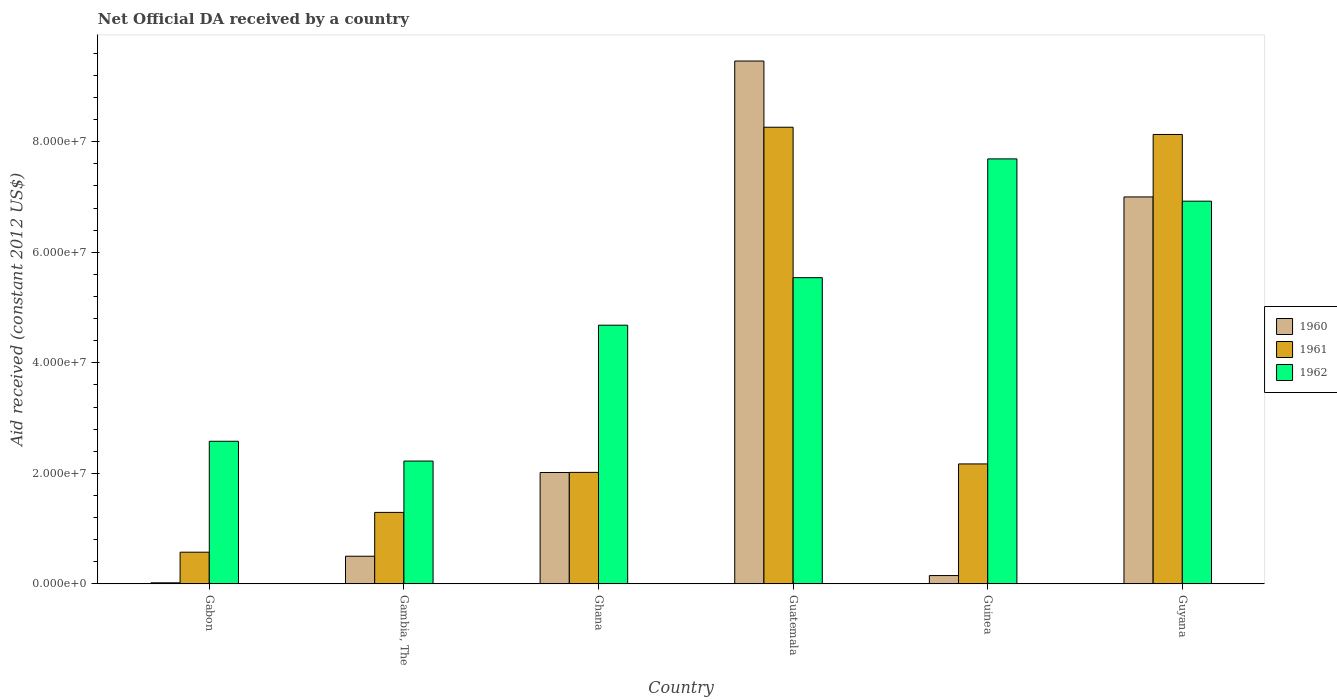How many different coloured bars are there?
Provide a short and direct response. 3. How many groups of bars are there?
Your answer should be very brief. 6. Are the number of bars on each tick of the X-axis equal?
Your answer should be compact. Yes. How many bars are there on the 2nd tick from the left?
Make the answer very short. 3. What is the label of the 6th group of bars from the left?
Keep it short and to the point. Guyana. What is the net official development assistance aid received in 1960 in Guatemala?
Provide a succinct answer. 9.46e+07. Across all countries, what is the maximum net official development assistance aid received in 1960?
Your response must be concise. 9.46e+07. Across all countries, what is the minimum net official development assistance aid received in 1962?
Give a very brief answer. 2.22e+07. In which country was the net official development assistance aid received in 1960 maximum?
Give a very brief answer. Guatemala. In which country was the net official development assistance aid received in 1962 minimum?
Your response must be concise. Gambia, The. What is the total net official development assistance aid received in 1961 in the graph?
Your answer should be compact. 2.24e+08. What is the difference between the net official development assistance aid received in 1962 in Guatemala and that in Guinea?
Ensure brevity in your answer.  -2.15e+07. What is the difference between the net official development assistance aid received in 1962 in Guatemala and the net official development assistance aid received in 1961 in Guyana?
Your answer should be compact. -2.59e+07. What is the average net official development assistance aid received in 1960 per country?
Provide a succinct answer. 3.19e+07. What is the difference between the net official development assistance aid received of/in 1961 and net official development assistance aid received of/in 1962 in Guyana?
Provide a short and direct response. 1.21e+07. What is the ratio of the net official development assistance aid received in 1960 in Gabon to that in Guyana?
Give a very brief answer. 0. Is the difference between the net official development assistance aid received in 1961 in Gabon and Gambia, The greater than the difference between the net official development assistance aid received in 1962 in Gabon and Gambia, The?
Your answer should be very brief. No. What is the difference between the highest and the second highest net official development assistance aid received in 1961?
Ensure brevity in your answer.  1.31e+06. What is the difference between the highest and the lowest net official development assistance aid received in 1962?
Ensure brevity in your answer.  5.47e+07. What does the 1st bar from the left in Guatemala represents?
Keep it short and to the point. 1960. Is it the case that in every country, the sum of the net official development assistance aid received in 1961 and net official development assistance aid received in 1960 is greater than the net official development assistance aid received in 1962?
Offer a terse response. No. How many bars are there?
Make the answer very short. 18. Are all the bars in the graph horizontal?
Give a very brief answer. No. What is the difference between two consecutive major ticks on the Y-axis?
Give a very brief answer. 2.00e+07. Are the values on the major ticks of Y-axis written in scientific E-notation?
Make the answer very short. Yes. Does the graph contain grids?
Ensure brevity in your answer.  No. Where does the legend appear in the graph?
Ensure brevity in your answer.  Center right. How are the legend labels stacked?
Make the answer very short. Vertical. What is the title of the graph?
Keep it short and to the point. Net Official DA received by a country. What is the label or title of the Y-axis?
Your response must be concise. Aid received (constant 2012 US$). What is the Aid received (constant 2012 US$) of 1960 in Gabon?
Offer a very short reply. 1.90e+05. What is the Aid received (constant 2012 US$) in 1961 in Gabon?
Your response must be concise. 5.73e+06. What is the Aid received (constant 2012 US$) of 1962 in Gabon?
Keep it short and to the point. 2.58e+07. What is the Aid received (constant 2012 US$) in 1961 in Gambia, The?
Ensure brevity in your answer.  1.29e+07. What is the Aid received (constant 2012 US$) in 1962 in Gambia, The?
Your answer should be very brief. 2.22e+07. What is the Aid received (constant 2012 US$) of 1960 in Ghana?
Your answer should be compact. 2.02e+07. What is the Aid received (constant 2012 US$) in 1961 in Ghana?
Give a very brief answer. 2.02e+07. What is the Aid received (constant 2012 US$) of 1962 in Ghana?
Your response must be concise. 4.68e+07. What is the Aid received (constant 2012 US$) of 1960 in Guatemala?
Your answer should be compact. 9.46e+07. What is the Aid received (constant 2012 US$) of 1961 in Guatemala?
Keep it short and to the point. 8.26e+07. What is the Aid received (constant 2012 US$) in 1962 in Guatemala?
Your answer should be compact. 5.54e+07. What is the Aid received (constant 2012 US$) in 1960 in Guinea?
Give a very brief answer. 1.50e+06. What is the Aid received (constant 2012 US$) in 1961 in Guinea?
Make the answer very short. 2.17e+07. What is the Aid received (constant 2012 US$) in 1962 in Guinea?
Make the answer very short. 7.69e+07. What is the Aid received (constant 2012 US$) of 1960 in Guyana?
Ensure brevity in your answer.  7.00e+07. What is the Aid received (constant 2012 US$) of 1961 in Guyana?
Make the answer very short. 8.13e+07. What is the Aid received (constant 2012 US$) of 1962 in Guyana?
Offer a very short reply. 6.92e+07. Across all countries, what is the maximum Aid received (constant 2012 US$) in 1960?
Keep it short and to the point. 9.46e+07. Across all countries, what is the maximum Aid received (constant 2012 US$) of 1961?
Your answer should be very brief. 8.26e+07. Across all countries, what is the maximum Aid received (constant 2012 US$) in 1962?
Make the answer very short. 7.69e+07. Across all countries, what is the minimum Aid received (constant 2012 US$) in 1961?
Provide a short and direct response. 5.73e+06. Across all countries, what is the minimum Aid received (constant 2012 US$) in 1962?
Ensure brevity in your answer.  2.22e+07. What is the total Aid received (constant 2012 US$) of 1960 in the graph?
Your answer should be very brief. 1.91e+08. What is the total Aid received (constant 2012 US$) of 1961 in the graph?
Provide a short and direct response. 2.24e+08. What is the total Aid received (constant 2012 US$) of 1962 in the graph?
Provide a short and direct response. 2.96e+08. What is the difference between the Aid received (constant 2012 US$) in 1960 in Gabon and that in Gambia, The?
Give a very brief answer. -4.81e+06. What is the difference between the Aid received (constant 2012 US$) of 1961 in Gabon and that in Gambia, The?
Give a very brief answer. -7.20e+06. What is the difference between the Aid received (constant 2012 US$) in 1962 in Gabon and that in Gambia, The?
Offer a terse response. 3.58e+06. What is the difference between the Aid received (constant 2012 US$) in 1960 in Gabon and that in Ghana?
Your response must be concise. -2.00e+07. What is the difference between the Aid received (constant 2012 US$) in 1961 in Gabon and that in Ghana?
Ensure brevity in your answer.  -1.44e+07. What is the difference between the Aid received (constant 2012 US$) of 1962 in Gabon and that in Ghana?
Make the answer very short. -2.10e+07. What is the difference between the Aid received (constant 2012 US$) of 1960 in Gabon and that in Guatemala?
Provide a succinct answer. -9.44e+07. What is the difference between the Aid received (constant 2012 US$) in 1961 in Gabon and that in Guatemala?
Your answer should be compact. -7.69e+07. What is the difference between the Aid received (constant 2012 US$) in 1962 in Gabon and that in Guatemala?
Your answer should be very brief. -2.96e+07. What is the difference between the Aid received (constant 2012 US$) of 1960 in Gabon and that in Guinea?
Keep it short and to the point. -1.31e+06. What is the difference between the Aid received (constant 2012 US$) in 1961 in Gabon and that in Guinea?
Provide a short and direct response. -1.60e+07. What is the difference between the Aid received (constant 2012 US$) of 1962 in Gabon and that in Guinea?
Provide a short and direct response. -5.11e+07. What is the difference between the Aid received (constant 2012 US$) of 1960 in Gabon and that in Guyana?
Provide a short and direct response. -6.98e+07. What is the difference between the Aid received (constant 2012 US$) in 1961 in Gabon and that in Guyana?
Your response must be concise. -7.56e+07. What is the difference between the Aid received (constant 2012 US$) of 1962 in Gabon and that in Guyana?
Make the answer very short. -4.34e+07. What is the difference between the Aid received (constant 2012 US$) in 1960 in Gambia, The and that in Ghana?
Your answer should be very brief. -1.52e+07. What is the difference between the Aid received (constant 2012 US$) in 1961 in Gambia, The and that in Ghana?
Provide a short and direct response. -7.24e+06. What is the difference between the Aid received (constant 2012 US$) in 1962 in Gambia, The and that in Ghana?
Give a very brief answer. -2.46e+07. What is the difference between the Aid received (constant 2012 US$) of 1960 in Gambia, The and that in Guatemala?
Your answer should be very brief. -8.96e+07. What is the difference between the Aid received (constant 2012 US$) in 1961 in Gambia, The and that in Guatemala?
Your answer should be very brief. -6.97e+07. What is the difference between the Aid received (constant 2012 US$) of 1962 in Gambia, The and that in Guatemala?
Provide a short and direct response. -3.32e+07. What is the difference between the Aid received (constant 2012 US$) of 1960 in Gambia, The and that in Guinea?
Your response must be concise. 3.50e+06. What is the difference between the Aid received (constant 2012 US$) in 1961 in Gambia, The and that in Guinea?
Provide a short and direct response. -8.77e+06. What is the difference between the Aid received (constant 2012 US$) of 1962 in Gambia, The and that in Guinea?
Give a very brief answer. -5.47e+07. What is the difference between the Aid received (constant 2012 US$) in 1960 in Gambia, The and that in Guyana?
Provide a succinct answer. -6.50e+07. What is the difference between the Aid received (constant 2012 US$) of 1961 in Gambia, The and that in Guyana?
Your answer should be very brief. -6.84e+07. What is the difference between the Aid received (constant 2012 US$) of 1962 in Gambia, The and that in Guyana?
Provide a short and direct response. -4.70e+07. What is the difference between the Aid received (constant 2012 US$) in 1960 in Ghana and that in Guatemala?
Offer a terse response. -7.44e+07. What is the difference between the Aid received (constant 2012 US$) in 1961 in Ghana and that in Guatemala?
Your answer should be very brief. -6.24e+07. What is the difference between the Aid received (constant 2012 US$) in 1962 in Ghana and that in Guatemala?
Keep it short and to the point. -8.60e+06. What is the difference between the Aid received (constant 2012 US$) in 1960 in Ghana and that in Guinea?
Provide a short and direct response. 1.86e+07. What is the difference between the Aid received (constant 2012 US$) of 1961 in Ghana and that in Guinea?
Give a very brief answer. -1.53e+06. What is the difference between the Aid received (constant 2012 US$) in 1962 in Ghana and that in Guinea?
Keep it short and to the point. -3.01e+07. What is the difference between the Aid received (constant 2012 US$) in 1960 in Ghana and that in Guyana?
Keep it short and to the point. -4.99e+07. What is the difference between the Aid received (constant 2012 US$) in 1961 in Ghana and that in Guyana?
Offer a terse response. -6.11e+07. What is the difference between the Aid received (constant 2012 US$) in 1962 in Ghana and that in Guyana?
Make the answer very short. -2.24e+07. What is the difference between the Aid received (constant 2012 US$) of 1960 in Guatemala and that in Guinea?
Your answer should be very brief. 9.31e+07. What is the difference between the Aid received (constant 2012 US$) in 1961 in Guatemala and that in Guinea?
Ensure brevity in your answer.  6.09e+07. What is the difference between the Aid received (constant 2012 US$) of 1962 in Guatemala and that in Guinea?
Your answer should be very brief. -2.15e+07. What is the difference between the Aid received (constant 2012 US$) of 1960 in Guatemala and that in Guyana?
Give a very brief answer. 2.46e+07. What is the difference between the Aid received (constant 2012 US$) of 1961 in Guatemala and that in Guyana?
Your response must be concise. 1.31e+06. What is the difference between the Aid received (constant 2012 US$) in 1962 in Guatemala and that in Guyana?
Give a very brief answer. -1.38e+07. What is the difference between the Aid received (constant 2012 US$) in 1960 in Guinea and that in Guyana?
Ensure brevity in your answer.  -6.85e+07. What is the difference between the Aid received (constant 2012 US$) in 1961 in Guinea and that in Guyana?
Provide a succinct answer. -5.96e+07. What is the difference between the Aid received (constant 2012 US$) in 1962 in Guinea and that in Guyana?
Provide a succinct answer. 7.65e+06. What is the difference between the Aid received (constant 2012 US$) of 1960 in Gabon and the Aid received (constant 2012 US$) of 1961 in Gambia, The?
Keep it short and to the point. -1.27e+07. What is the difference between the Aid received (constant 2012 US$) in 1960 in Gabon and the Aid received (constant 2012 US$) in 1962 in Gambia, The?
Provide a succinct answer. -2.20e+07. What is the difference between the Aid received (constant 2012 US$) in 1961 in Gabon and the Aid received (constant 2012 US$) in 1962 in Gambia, The?
Your answer should be very brief. -1.65e+07. What is the difference between the Aid received (constant 2012 US$) in 1960 in Gabon and the Aid received (constant 2012 US$) in 1961 in Ghana?
Ensure brevity in your answer.  -2.00e+07. What is the difference between the Aid received (constant 2012 US$) of 1960 in Gabon and the Aid received (constant 2012 US$) of 1962 in Ghana?
Ensure brevity in your answer.  -4.66e+07. What is the difference between the Aid received (constant 2012 US$) of 1961 in Gabon and the Aid received (constant 2012 US$) of 1962 in Ghana?
Your answer should be very brief. -4.11e+07. What is the difference between the Aid received (constant 2012 US$) of 1960 in Gabon and the Aid received (constant 2012 US$) of 1961 in Guatemala?
Make the answer very short. -8.24e+07. What is the difference between the Aid received (constant 2012 US$) of 1960 in Gabon and the Aid received (constant 2012 US$) of 1962 in Guatemala?
Ensure brevity in your answer.  -5.52e+07. What is the difference between the Aid received (constant 2012 US$) in 1961 in Gabon and the Aid received (constant 2012 US$) in 1962 in Guatemala?
Offer a terse response. -4.97e+07. What is the difference between the Aid received (constant 2012 US$) in 1960 in Gabon and the Aid received (constant 2012 US$) in 1961 in Guinea?
Your answer should be very brief. -2.15e+07. What is the difference between the Aid received (constant 2012 US$) in 1960 in Gabon and the Aid received (constant 2012 US$) in 1962 in Guinea?
Offer a very short reply. -7.67e+07. What is the difference between the Aid received (constant 2012 US$) in 1961 in Gabon and the Aid received (constant 2012 US$) in 1962 in Guinea?
Provide a succinct answer. -7.12e+07. What is the difference between the Aid received (constant 2012 US$) of 1960 in Gabon and the Aid received (constant 2012 US$) of 1961 in Guyana?
Keep it short and to the point. -8.11e+07. What is the difference between the Aid received (constant 2012 US$) in 1960 in Gabon and the Aid received (constant 2012 US$) in 1962 in Guyana?
Offer a very short reply. -6.90e+07. What is the difference between the Aid received (constant 2012 US$) in 1961 in Gabon and the Aid received (constant 2012 US$) in 1962 in Guyana?
Offer a terse response. -6.35e+07. What is the difference between the Aid received (constant 2012 US$) of 1960 in Gambia, The and the Aid received (constant 2012 US$) of 1961 in Ghana?
Make the answer very short. -1.52e+07. What is the difference between the Aid received (constant 2012 US$) in 1960 in Gambia, The and the Aid received (constant 2012 US$) in 1962 in Ghana?
Your response must be concise. -4.18e+07. What is the difference between the Aid received (constant 2012 US$) of 1961 in Gambia, The and the Aid received (constant 2012 US$) of 1962 in Ghana?
Make the answer very short. -3.39e+07. What is the difference between the Aid received (constant 2012 US$) of 1960 in Gambia, The and the Aid received (constant 2012 US$) of 1961 in Guatemala?
Offer a very short reply. -7.76e+07. What is the difference between the Aid received (constant 2012 US$) in 1960 in Gambia, The and the Aid received (constant 2012 US$) in 1962 in Guatemala?
Offer a terse response. -5.04e+07. What is the difference between the Aid received (constant 2012 US$) in 1961 in Gambia, The and the Aid received (constant 2012 US$) in 1962 in Guatemala?
Offer a very short reply. -4.25e+07. What is the difference between the Aid received (constant 2012 US$) in 1960 in Gambia, The and the Aid received (constant 2012 US$) in 1961 in Guinea?
Your answer should be very brief. -1.67e+07. What is the difference between the Aid received (constant 2012 US$) in 1960 in Gambia, The and the Aid received (constant 2012 US$) in 1962 in Guinea?
Your response must be concise. -7.19e+07. What is the difference between the Aid received (constant 2012 US$) of 1961 in Gambia, The and the Aid received (constant 2012 US$) of 1962 in Guinea?
Ensure brevity in your answer.  -6.40e+07. What is the difference between the Aid received (constant 2012 US$) of 1960 in Gambia, The and the Aid received (constant 2012 US$) of 1961 in Guyana?
Offer a terse response. -7.63e+07. What is the difference between the Aid received (constant 2012 US$) in 1960 in Gambia, The and the Aid received (constant 2012 US$) in 1962 in Guyana?
Provide a short and direct response. -6.42e+07. What is the difference between the Aid received (constant 2012 US$) in 1961 in Gambia, The and the Aid received (constant 2012 US$) in 1962 in Guyana?
Ensure brevity in your answer.  -5.63e+07. What is the difference between the Aid received (constant 2012 US$) in 1960 in Ghana and the Aid received (constant 2012 US$) in 1961 in Guatemala?
Ensure brevity in your answer.  -6.25e+07. What is the difference between the Aid received (constant 2012 US$) in 1960 in Ghana and the Aid received (constant 2012 US$) in 1962 in Guatemala?
Make the answer very short. -3.52e+07. What is the difference between the Aid received (constant 2012 US$) of 1961 in Ghana and the Aid received (constant 2012 US$) of 1962 in Guatemala?
Offer a very short reply. -3.52e+07. What is the difference between the Aid received (constant 2012 US$) in 1960 in Ghana and the Aid received (constant 2012 US$) in 1961 in Guinea?
Give a very brief answer. -1.55e+06. What is the difference between the Aid received (constant 2012 US$) in 1960 in Ghana and the Aid received (constant 2012 US$) in 1962 in Guinea?
Give a very brief answer. -5.67e+07. What is the difference between the Aid received (constant 2012 US$) of 1961 in Ghana and the Aid received (constant 2012 US$) of 1962 in Guinea?
Provide a short and direct response. -5.67e+07. What is the difference between the Aid received (constant 2012 US$) in 1960 in Ghana and the Aid received (constant 2012 US$) in 1961 in Guyana?
Give a very brief answer. -6.12e+07. What is the difference between the Aid received (constant 2012 US$) of 1960 in Ghana and the Aid received (constant 2012 US$) of 1962 in Guyana?
Offer a very short reply. -4.91e+07. What is the difference between the Aid received (constant 2012 US$) in 1961 in Ghana and the Aid received (constant 2012 US$) in 1962 in Guyana?
Offer a terse response. -4.91e+07. What is the difference between the Aid received (constant 2012 US$) in 1960 in Guatemala and the Aid received (constant 2012 US$) in 1961 in Guinea?
Your answer should be very brief. 7.29e+07. What is the difference between the Aid received (constant 2012 US$) of 1960 in Guatemala and the Aid received (constant 2012 US$) of 1962 in Guinea?
Provide a short and direct response. 1.77e+07. What is the difference between the Aid received (constant 2012 US$) of 1961 in Guatemala and the Aid received (constant 2012 US$) of 1962 in Guinea?
Your answer should be very brief. 5.73e+06. What is the difference between the Aid received (constant 2012 US$) in 1960 in Guatemala and the Aid received (constant 2012 US$) in 1961 in Guyana?
Make the answer very short. 1.33e+07. What is the difference between the Aid received (constant 2012 US$) in 1960 in Guatemala and the Aid received (constant 2012 US$) in 1962 in Guyana?
Your answer should be very brief. 2.54e+07. What is the difference between the Aid received (constant 2012 US$) of 1961 in Guatemala and the Aid received (constant 2012 US$) of 1962 in Guyana?
Offer a very short reply. 1.34e+07. What is the difference between the Aid received (constant 2012 US$) in 1960 in Guinea and the Aid received (constant 2012 US$) in 1961 in Guyana?
Your answer should be very brief. -7.98e+07. What is the difference between the Aid received (constant 2012 US$) in 1960 in Guinea and the Aid received (constant 2012 US$) in 1962 in Guyana?
Your answer should be very brief. -6.77e+07. What is the difference between the Aid received (constant 2012 US$) in 1961 in Guinea and the Aid received (constant 2012 US$) in 1962 in Guyana?
Offer a terse response. -4.75e+07. What is the average Aid received (constant 2012 US$) in 1960 per country?
Make the answer very short. 3.19e+07. What is the average Aid received (constant 2012 US$) in 1961 per country?
Make the answer very short. 3.74e+07. What is the average Aid received (constant 2012 US$) of 1962 per country?
Your response must be concise. 4.94e+07. What is the difference between the Aid received (constant 2012 US$) in 1960 and Aid received (constant 2012 US$) in 1961 in Gabon?
Offer a terse response. -5.54e+06. What is the difference between the Aid received (constant 2012 US$) in 1960 and Aid received (constant 2012 US$) in 1962 in Gabon?
Your response must be concise. -2.56e+07. What is the difference between the Aid received (constant 2012 US$) in 1961 and Aid received (constant 2012 US$) in 1962 in Gabon?
Make the answer very short. -2.01e+07. What is the difference between the Aid received (constant 2012 US$) in 1960 and Aid received (constant 2012 US$) in 1961 in Gambia, The?
Keep it short and to the point. -7.93e+06. What is the difference between the Aid received (constant 2012 US$) in 1960 and Aid received (constant 2012 US$) in 1962 in Gambia, The?
Offer a terse response. -1.72e+07. What is the difference between the Aid received (constant 2012 US$) of 1961 and Aid received (constant 2012 US$) of 1962 in Gambia, The?
Offer a terse response. -9.29e+06. What is the difference between the Aid received (constant 2012 US$) of 1960 and Aid received (constant 2012 US$) of 1962 in Ghana?
Your answer should be very brief. -2.66e+07. What is the difference between the Aid received (constant 2012 US$) of 1961 and Aid received (constant 2012 US$) of 1962 in Ghana?
Your answer should be very brief. -2.66e+07. What is the difference between the Aid received (constant 2012 US$) of 1960 and Aid received (constant 2012 US$) of 1961 in Guatemala?
Your answer should be compact. 1.20e+07. What is the difference between the Aid received (constant 2012 US$) in 1960 and Aid received (constant 2012 US$) in 1962 in Guatemala?
Your response must be concise. 3.92e+07. What is the difference between the Aid received (constant 2012 US$) of 1961 and Aid received (constant 2012 US$) of 1962 in Guatemala?
Provide a succinct answer. 2.72e+07. What is the difference between the Aid received (constant 2012 US$) in 1960 and Aid received (constant 2012 US$) in 1961 in Guinea?
Provide a succinct answer. -2.02e+07. What is the difference between the Aid received (constant 2012 US$) of 1960 and Aid received (constant 2012 US$) of 1962 in Guinea?
Give a very brief answer. -7.54e+07. What is the difference between the Aid received (constant 2012 US$) of 1961 and Aid received (constant 2012 US$) of 1962 in Guinea?
Provide a succinct answer. -5.52e+07. What is the difference between the Aid received (constant 2012 US$) of 1960 and Aid received (constant 2012 US$) of 1961 in Guyana?
Offer a terse response. -1.13e+07. What is the difference between the Aid received (constant 2012 US$) in 1960 and Aid received (constant 2012 US$) in 1962 in Guyana?
Give a very brief answer. 7.70e+05. What is the difference between the Aid received (constant 2012 US$) in 1961 and Aid received (constant 2012 US$) in 1962 in Guyana?
Ensure brevity in your answer.  1.21e+07. What is the ratio of the Aid received (constant 2012 US$) of 1960 in Gabon to that in Gambia, The?
Your response must be concise. 0.04. What is the ratio of the Aid received (constant 2012 US$) of 1961 in Gabon to that in Gambia, The?
Ensure brevity in your answer.  0.44. What is the ratio of the Aid received (constant 2012 US$) of 1962 in Gabon to that in Gambia, The?
Ensure brevity in your answer.  1.16. What is the ratio of the Aid received (constant 2012 US$) of 1960 in Gabon to that in Ghana?
Your answer should be very brief. 0.01. What is the ratio of the Aid received (constant 2012 US$) in 1961 in Gabon to that in Ghana?
Give a very brief answer. 0.28. What is the ratio of the Aid received (constant 2012 US$) in 1962 in Gabon to that in Ghana?
Provide a short and direct response. 0.55. What is the ratio of the Aid received (constant 2012 US$) in 1960 in Gabon to that in Guatemala?
Provide a succinct answer. 0. What is the ratio of the Aid received (constant 2012 US$) of 1961 in Gabon to that in Guatemala?
Offer a terse response. 0.07. What is the ratio of the Aid received (constant 2012 US$) of 1962 in Gabon to that in Guatemala?
Your response must be concise. 0.47. What is the ratio of the Aid received (constant 2012 US$) in 1960 in Gabon to that in Guinea?
Your response must be concise. 0.13. What is the ratio of the Aid received (constant 2012 US$) of 1961 in Gabon to that in Guinea?
Provide a succinct answer. 0.26. What is the ratio of the Aid received (constant 2012 US$) in 1962 in Gabon to that in Guinea?
Offer a very short reply. 0.34. What is the ratio of the Aid received (constant 2012 US$) in 1960 in Gabon to that in Guyana?
Keep it short and to the point. 0. What is the ratio of the Aid received (constant 2012 US$) of 1961 in Gabon to that in Guyana?
Give a very brief answer. 0.07. What is the ratio of the Aid received (constant 2012 US$) of 1962 in Gabon to that in Guyana?
Keep it short and to the point. 0.37. What is the ratio of the Aid received (constant 2012 US$) of 1960 in Gambia, The to that in Ghana?
Your answer should be very brief. 0.25. What is the ratio of the Aid received (constant 2012 US$) in 1961 in Gambia, The to that in Ghana?
Offer a very short reply. 0.64. What is the ratio of the Aid received (constant 2012 US$) of 1962 in Gambia, The to that in Ghana?
Make the answer very short. 0.47. What is the ratio of the Aid received (constant 2012 US$) of 1960 in Gambia, The to that in Guatemala?
Provide a succinct answer. 0.05. What is the ratio of the Aid received (constant 2012 US$) of 1961 in Gambia, The to that in Guatemala?
Offer a very short reply. 0.16. What is the ratio of the Aid received (constant 2012 US$) in 1962 in Gambia, The to that in Guatemala?
Give a very brief answer. 0.4. What is the ratio of the Aid received (constant 2012 US$) in 1961 in Gambia, The to that in Guinea?
Make the answer very short. 0.6. What is the ratio of the Aid received (constant 2012 US$) of 1962 in Gambia, The to that in Guinea?
Your answer should be very brief. 0.29. What is the ratio of the Aid received (constant 2012 US$) of 1960 in Gambia, The to that in Guyana?
Give a very brief answer. 0.07. What is the ratio of the Aid received (constant 2012 US$) of 1961 in Gambia, The to that in Guyana?
Your answer should be compact. 0.16. What is the ratio of the Aid received (constant 2012 US$) in 1962 in Gambia, The to that in Guyana?
Keep it short and to the point. 0.32. What is the ratio of the Aid received (constant 2012 US$) in 1960 in Ghana to that in Guatemala?
Ensure brevity in your answer.  0.21. What is the ratio of the Aid received (constant 2012 US$) in 1961 in Ghana to that in Guatemala?
Make the answer very short. 0.24. What is the ratio of the Aid received (constant 2012 US$) of 1962 in Ghana to that in Guatemala?
Provide a succinct answer. 0.84. What is the ratio of the Aid received (constant 2012 US$) in 1960 in Ghana to that in Guinea?
Keep it short and to the point. 13.43. What is the ratio of the Aid received (constant 2012 US$) of 1961 in Ghana to that in Guinea?
Your answer should be compact. 0.93. What is the ratio of the Aid received (constant 2012 US$) of 1962 in Ghana to that in Guinea?
Ensure brevity in your answer.  0.61. What is the ratio of the Aid received (constant 2012 US$) of 1960 in Ghana to that in Guyana?
Give a very brief answer. 0.29. What is the ratio of the Aid received (constant 2012 US$) of 1961 in Ghana to that in Guyana?
Offer a very short reply. 0.25. What is the ratio of the Aid received (constant 2012 US$) in 1962 in Ghana to that in Guyana?
Your answer should be compact. 0.68. What is the ratio of the Aid received (constant 2012 US$) in 1960 in Guatemala to that in Guinea?
Provide a succinct answer. 63.07. What is the ratio of the Aid received (constant 2012 US$) in 1961 in Guatemala to that in Guinea?
Offer a very short reply. 3.81. What is the ratio of the Aid received (constant 2012 US$) of 1962 in Guatemala to that in Guinea?
Ensure brevity in your answer.  0.72. What is the ratio of the Aid received (constant 2012 US$) of 1960 in Guatemala to that in Guyana?
Offer a terse response. 1.35. What is the ratio of the Aid received (constant 2012 US$) of 1961 in Guatemala to that in Guyana?
Your response must be concise. 1.02. What is the ratio of the Aid received (constant 2012 US$) in 1962 in Guatemala to that in Guyana?
Offer a very short reply. 0.8. What is the ratio of the Aid received (constant 2012 US$) in 1960 in Guinea to that in Guyana?
Provide a short and direct response. 0.02. What is the ratio of the Aid received (constant 2012 US$) of 1961 in Guinea to that in Guyana?
Keep it short and to the point. 0.27. What is the ratio of the Aid received (constant 2012 US$) in 1962 in Guinea to that in Guyana?
Ensure brevity in your answer.  1.11. What is the difference between the highest and the second highest Aid received (constant 2012 US$) of 1960?
Offer a terse response. 2.46e+07. What is the difference between the highest and the second highest Aid received (constant 2012 US$) of 1961?
Your answer should be very brief. 1.31e+06. What is the difference between the highest and the second highest Aid received (constant 2012 US$) in 1962?
Keep it short and to the point. 7.65e+06. What is the difference between the highest and the lowest Aid received (constant 2012 US$) of 1960?
Ensure brevity in your answer.  9.44e+07. What is the difference between the highest and the lowest Aid received (constant 2012 US$) in 1961?
Provide a short and direct response. 7.69e+07. What is the difference between the highest and the lowest Aid received (constant 2012 US$) in 1962?
Ensure brevity in your answer.  5.47e+07. 